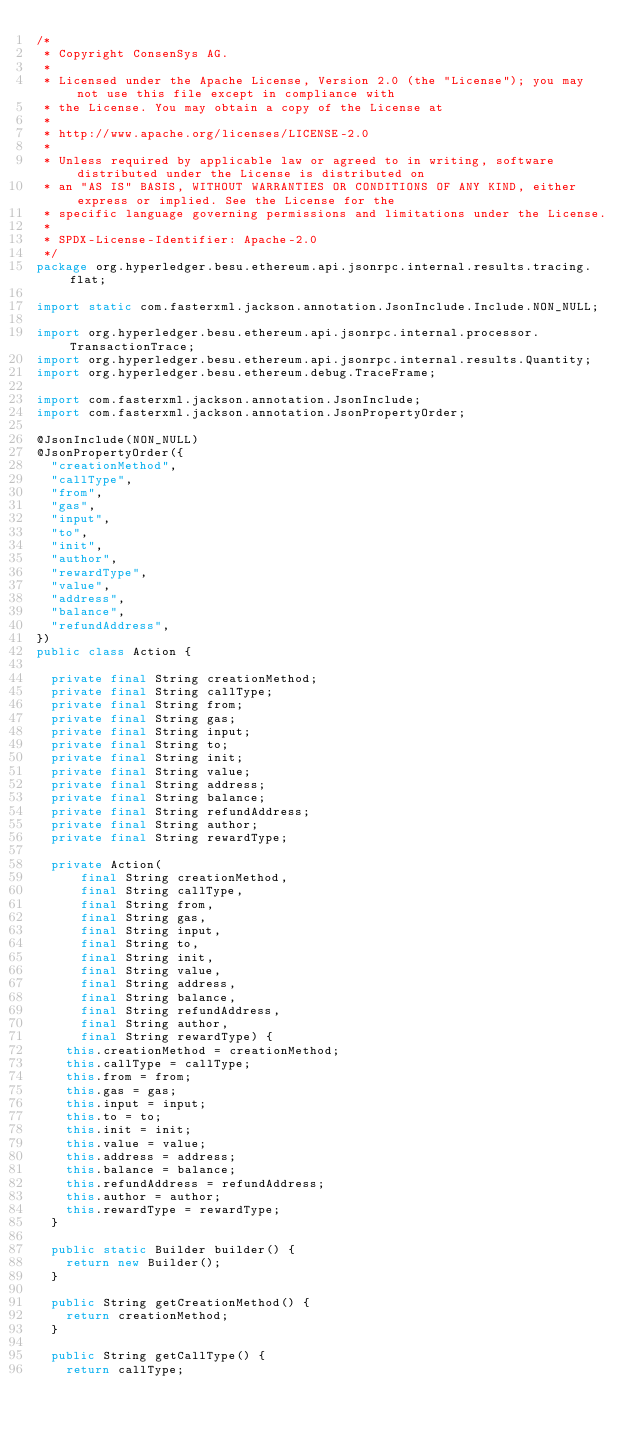<code> <loc_0><loc_0><loc_500><loc_500><_Java_>/*
 * Copyright ConsenSys AG.
 *
 * Licensed under the Apache License, Version 2.0 (the "License"); you may not use this file except in compliance with
 * the License. You may obtain a copy of the License at
 *
 * http://www.apache.org/licenses/LICENSE-2.0
 *
 * Unless required by applicable law or agreed to in writing, software distributed under the License is distributed on
 * an "AS IS" BASIS, WITHOUT WARRANTIES OR CONDITIONS OF ANY KIND, either express or implied. See the License for the
 * specific language governing permissions and limitations under the License.
 *
 * SPDX-License-Identifier: Apache-2.0
 */
package org.hyperledger.besu.ethereum.api.jsonrpc.internal.results.tracing.flat;

import static com.fasterxml.jackson.annotation.JsonInclude.Include.NON_NULL;

import org.hyperledger.besu.ethereum.api.jsonrpc.internal.processor.TransactionTrace;
import org.hyperledger.besu.ethereum.api.jsonrpc.internal.results.Quantity;
import org.hyperledger.besu.ethereum.debug.TraceFrame;

import com.fasterxml.jackson.annotation.JsonInclude;
import com.fasterxml.jackson.annotation.JsonPropertyOrder;

@JsonInclude(NON_NULL)
@JsonPropertyOrder({
  "creationMethod",
  "callType",
  "from",
  "gas",
  "input",
  "to",
  "init",
  "author",
  "rewardType",
  "value",
  "address",
  "balance",
  "refundAddress",
})
public class Action {

  private final String creationMethod;
  private final String callType;
  private final String from;
  private final String gas;
  private final String input;
  private final String to;
  private final String init;
  private final String value;
  private final String address;
  private final String balance;
  private final String refundAddress;
  private final String author;
  private final String rewardType;

  private Action(
      final String creationMethod,
      final String callType,
      final String from,
      final String gas,
      final String input,
      final String to,
      final String init,
      final String value,
      final String address,
      final String balance,
      final String refundAddress,
      final String author,
      final String rewardType) {
    this.creationMethod = creationMethod;
    this.callType = callType;
    this.from = from;
    this.gas = gas;
    this.input = input;
    this.to = to;
    this.init = init;
    this.value = value;
    this.address = address;
    this.balance = balance;
    this.refundAddress = refundAddress;
    this.author = author;
    this.rewardType = rewardType;
  }

  public static Builder builder() {
    return new Builder();
  }

  public String getCreationMethod() {
    return creationMethod;
  }

  public String getCallType() {
    return callType;</code> 